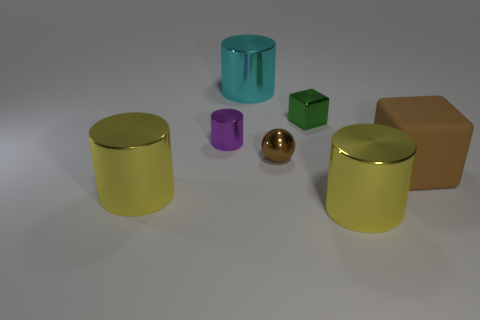What material is the cube that is on the left side of the rubber thing?
Your answer should be very brief. Metal. What number of other things are the same shape as the large brown object?
Offer a terse response. 1. Is the shape of the purple shiny thing the same as the matte thing?
Your answer should be very brief. No. Are there any small shiny spheres left of the tiny brown object?
Keep it short and to the point. No. How many things are yellow shiny cylinders or large cyan shiny things?
Offer a very short reply. 3. What number of other things are there of the same size as the brown rubber thing?
Your answer should be very brief. 3. What number of metallic objects are in front of the brown rubber thing and right of the big cyan metallic thing?
Your answer should be compact. 1. Is the size of the block in front of the small metal cube the same as the cylinder behind the tiny green metal object?
Your response must be concise. Yes. What is the size of the yellow cylinder to the right of the small cylinder?
Give a very brief answer. Large. What number of things are either metal objects that are in front of the small shiny cube or small brown metallic balls that are left of the green shiny block?
Your answer should be very brief. 4. 